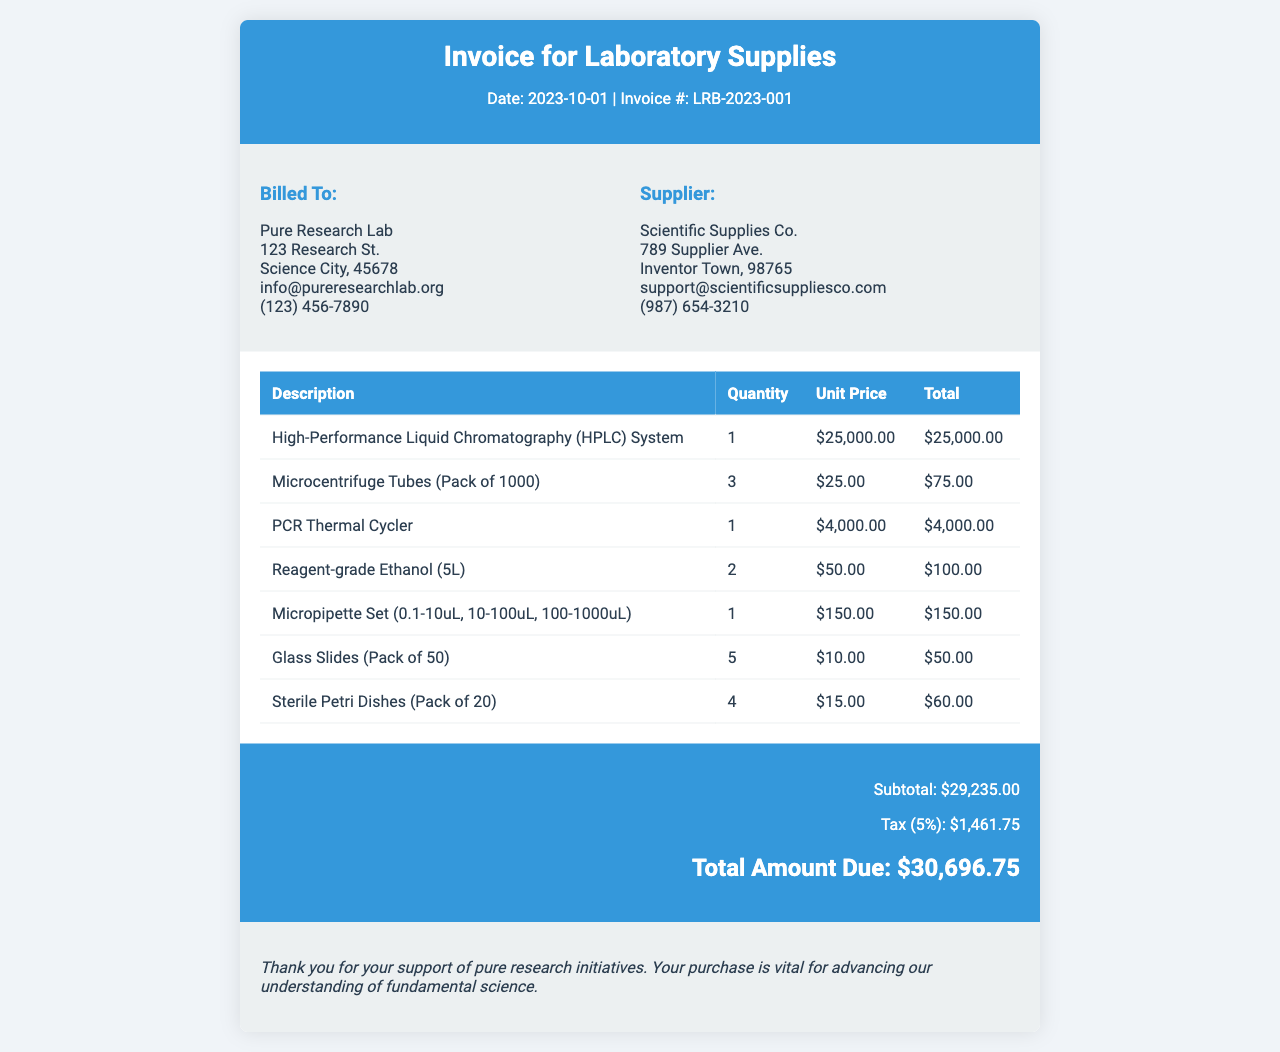what is the invoice number? The invoice number is provided at the top of the document.
Answer: LRB-2023-001 who is billed to? The "Billed To" section provides the name and details of the entity.
Answer: Pure Research Lab what is the total amount due? The total amount due is the final amount listed in the summary at the bottom.
Answer: $30,696.75 how many microcentrifuge tubes were purchased? The quantity of microcentrifuge tubes is listed in the invoice items section.
Answer: 3 what is the subtotal before tax? The subtotal is the amount before adding tax, listed in the invoice summary.
Answer: $29,235.00 how much tax was charged? The tax amount is specified in the invoice summary and indicates the calculated tax on the subtotal.
Answer: $1,461.75 what is the supplier's contact email? The supplier's contact email is found in the address block for the supplier.
Answer: support@scientificsuppliesco.com how many sterile petri dishes are included in the order? The quantity of sterilized petri dishes is detailed in the items section of the invoice.
Answer: 4 what is the unit price of the HPLC system? The unit price can be found next to the description of the HPLC system in the invoice items.
Answer: $25,000.00 